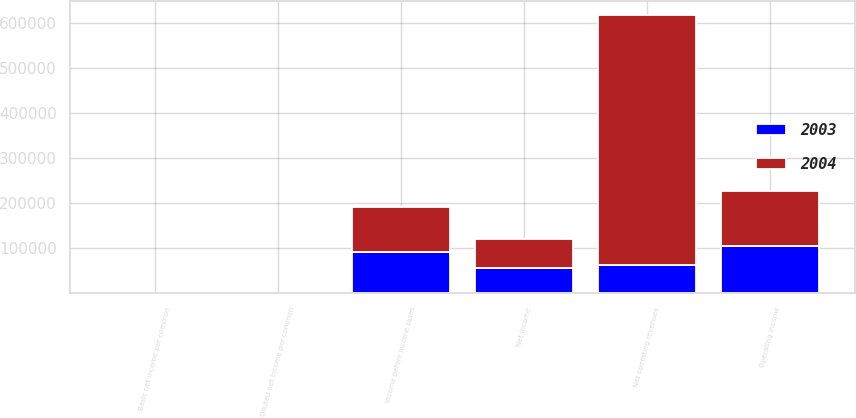Convert chart. <chart><loc_0><loc_0><loc_500><loc_500><stacked_bar_chart><ecel><fcel>Net operating revenues<fcel>Operating income<fcel>Income before income taxes<fcel>Net income<fcel>Basic net income per common<fcel>Diluted net income per common<nl><fcel>2003<fcel>62798<fcel>105171<fcel>90447<fcel>56602<fcel>0.58<fcel>0.56<nl><fcel>2004<fcel>553446<fcel>121190<fcel>100498<fcel>62798<fcel>0.65<fcel>0.61<nl></chart> 